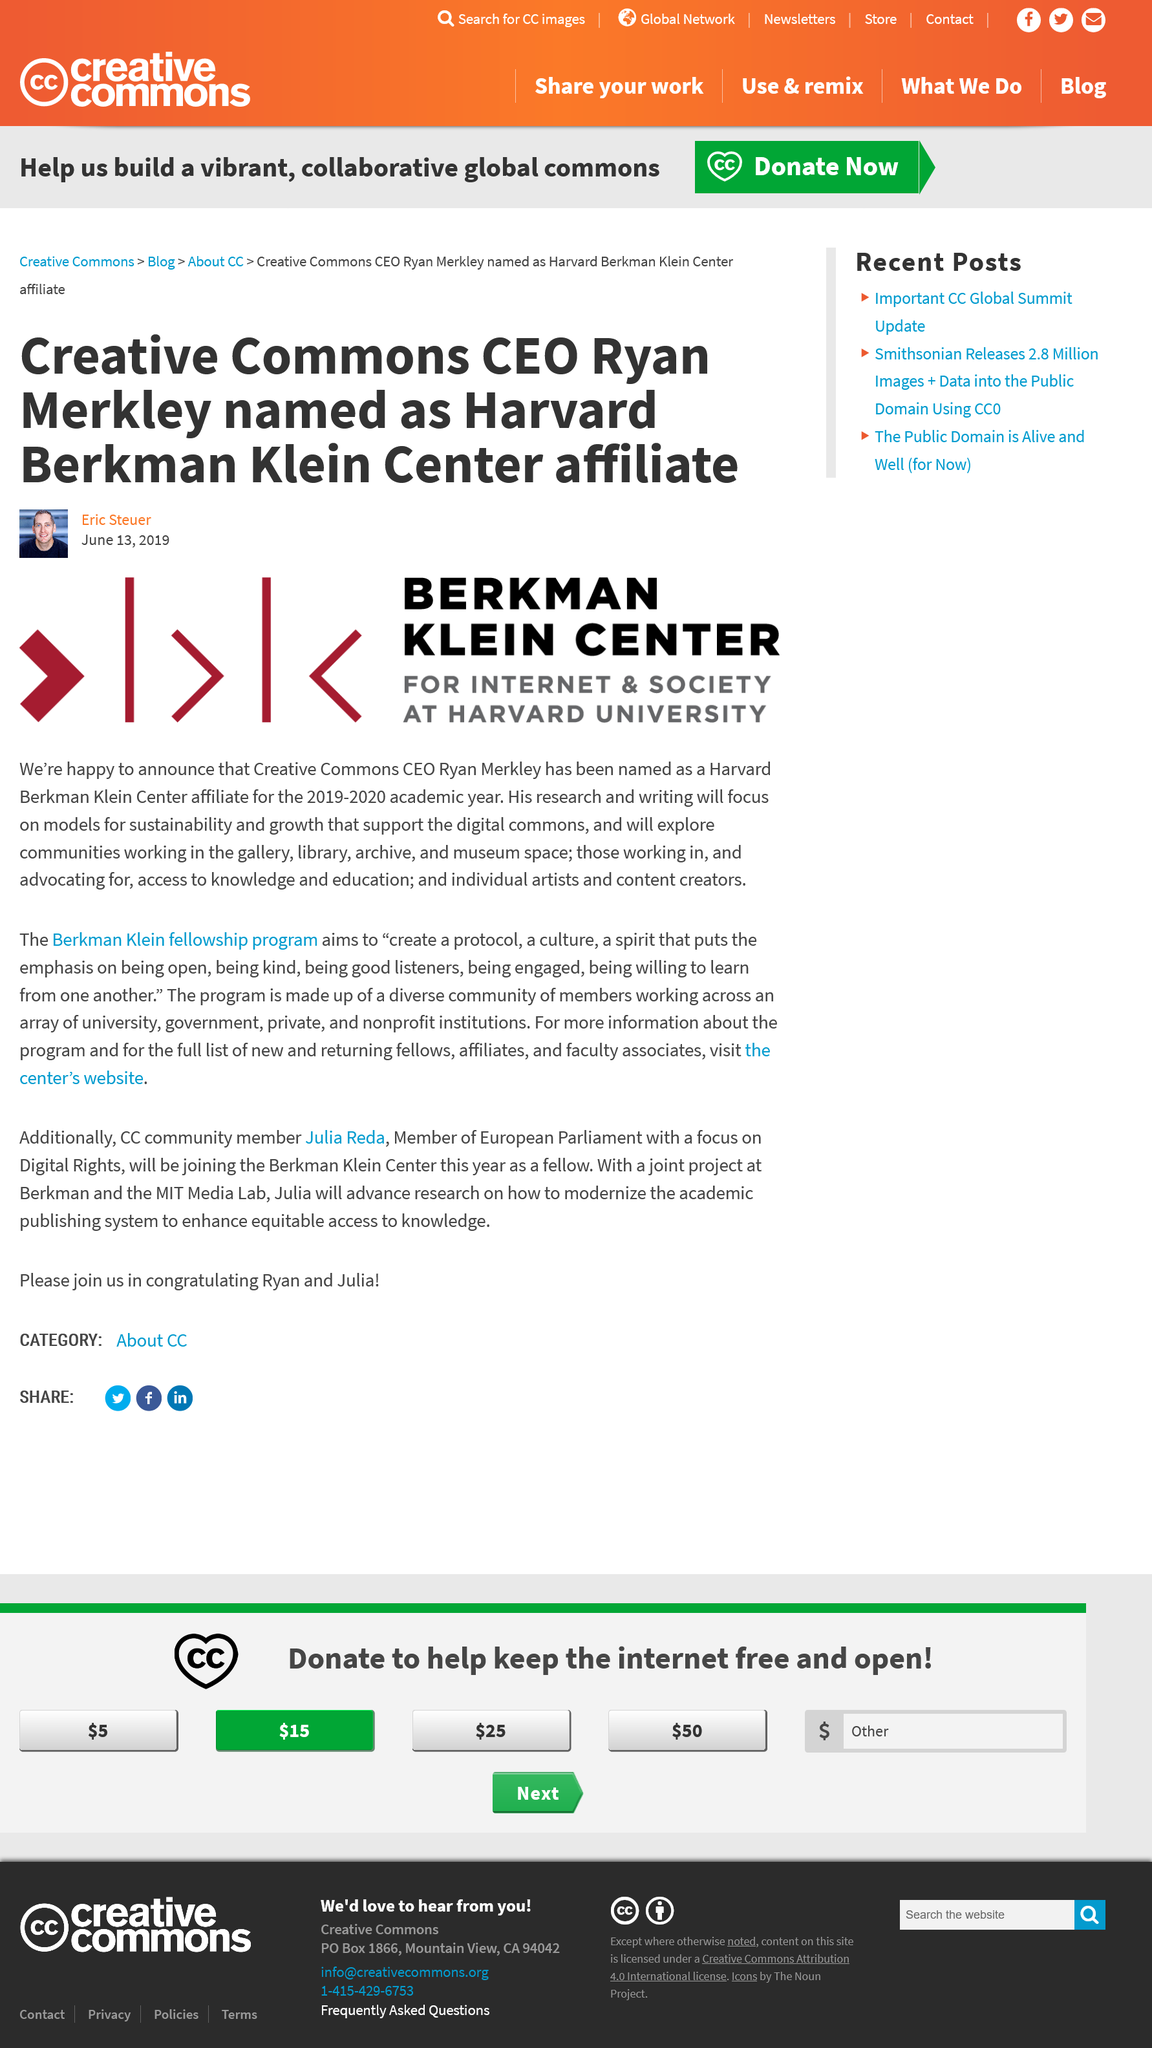Give some essential details in this illustration. The Berkman Klein Center for Internet and Society is devoted to studying and advancing the intersection of internet and society. Your research will primarily focus on developing models for sustainability and growth that prioritize the protection and preservation of the digital commons. Our research is focused on communities working in the gallery, library, archive, and museum space. 